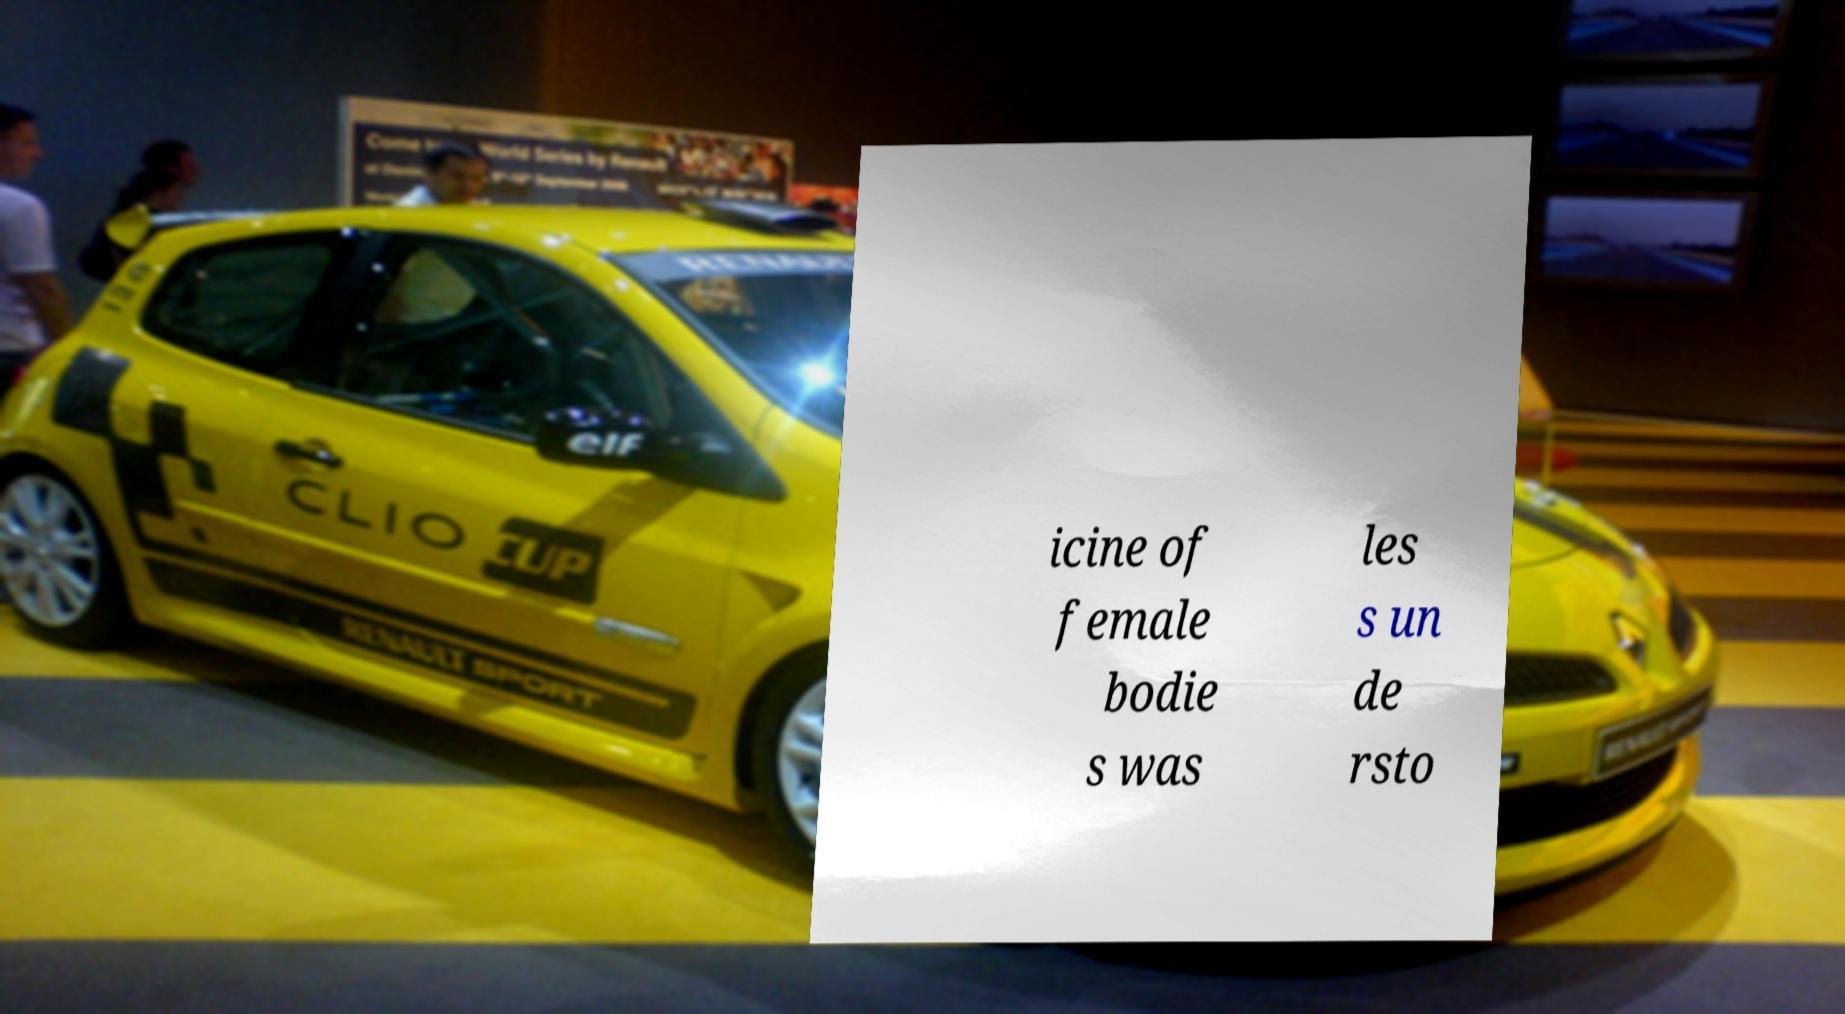For documentation purposes, I need the text within this image transcribed. Could you provide that? icine of female bodie s was les s un de rsto 